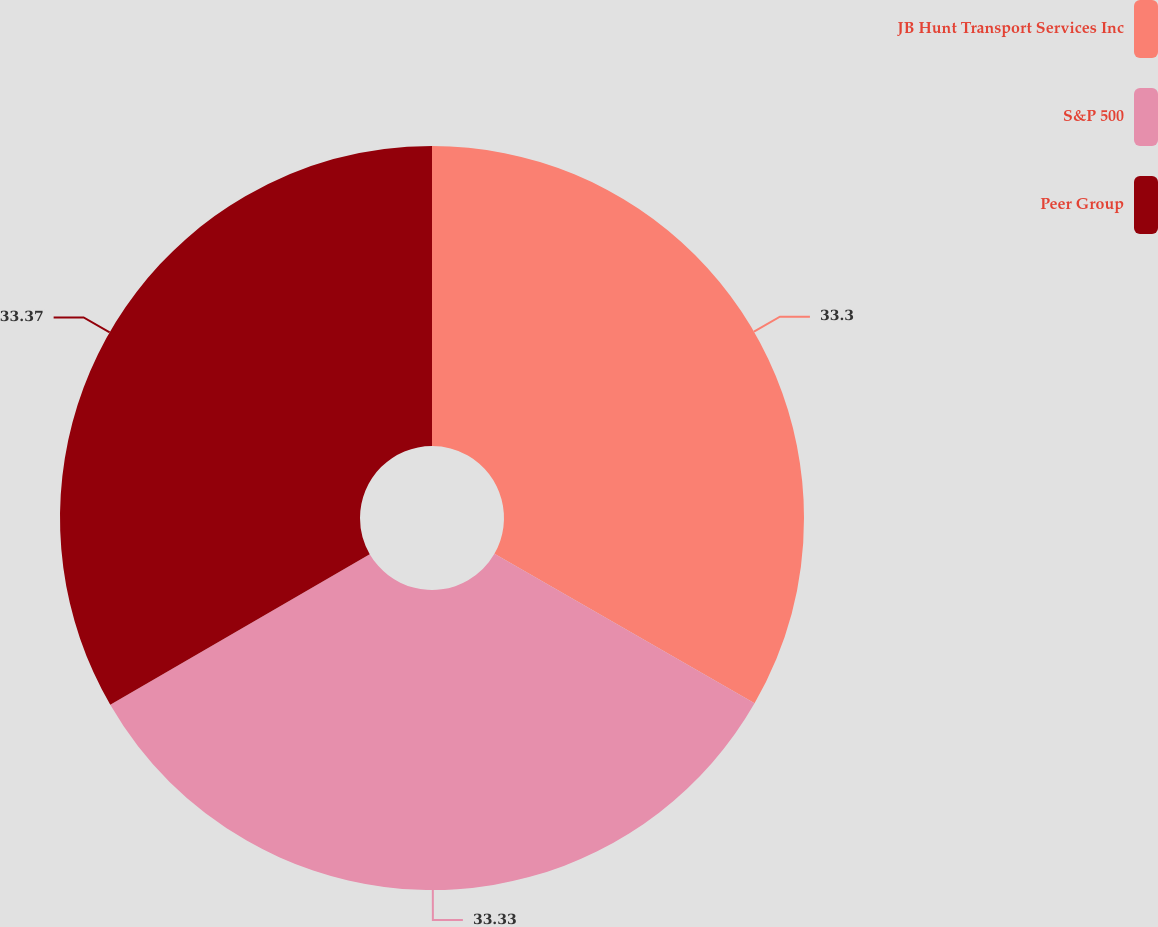<chart> <loc_0><loc_0><loc_500><loc_500><pie_chart><fcel>JB Hunt Transport Services Inc<fcel>S&P 500<fcel>Peer Group<nl><fcel>33.3%<fcel>33.33%<fcel>33.37%<nl></chart> 